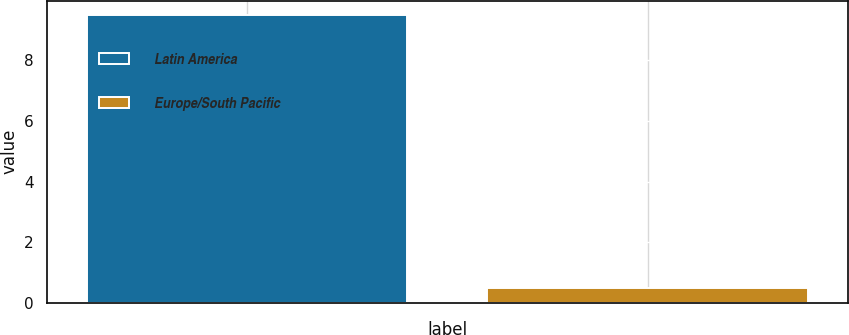Convert chart to OTSL. <chart><loc_0><loc_0><loc_500><loc_500><bar_chart><fcel>Latin America<fcel>Europe/South Pacific<nl><fcel>9.5<fcel>0.5<nl></chart> 